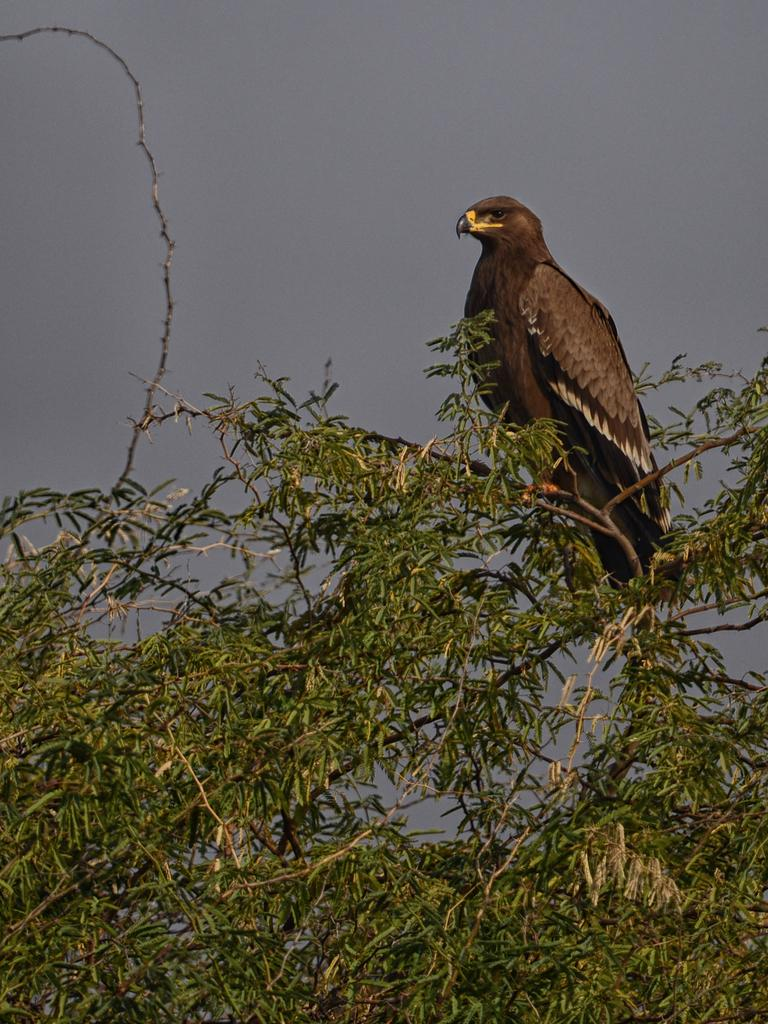What type of animal can be seen in the image? There is a bird in the image. Where is the bird located in the image? The bird is on a tree. What is visible at the top of the image? The sky is visible at the top of the image. Can you tell me how many times the creature sneezes in the image? There is no creature present in the image, and therefore no sneezing can be observed. What type of bushes can be seen surrounding the tree in the image? There is no mention of bushes in the provided facts, and therefore we cannot determine if any bushes are present in the image. 